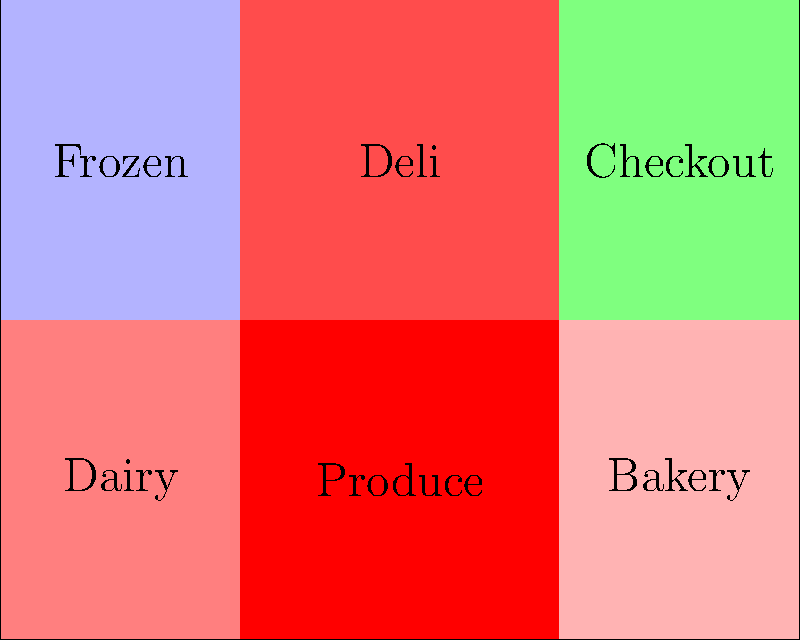Looking at the heat map of your store, which section seems to have the highest customer traffic, and what could you do to potentially increase sales in that area? To answer this question, let's analyze the heat map step-by-step:

1. The heat map uses colors to represent customer traffic, with red indicating high traffic and blue indicating low traffic.

2. Looking at the map, we can see that the Produce section is colored the darkest red, indicating it has the highest customer traffic.

3. The Deli section is the second most visited area, with a slightly lighter shade of red.

4. The Dairy and Bakery sections have moderate traffic, shown by lighter shades of red.

5. The Frozen section has the lowest traffic, indicated by the blue color.

6. The Checkout area is green, which likely represents a moderate but steady flow of customers.

To potentially increase sales in the high-traffic Produce section, you could:

1. Ensure ample stock of popular produce items to meet demand.
2. Place high-margin items or complementary products (like salad dressings or fruit dips) near popular produce.
3. Use attractive displays to showcase seasonal or specialty produce.
4. Offer samples of unique or new produce items to encourage purchases.
5. Place signs with recipe ideas using produce items to inspire additional purchases.

These strategies can help capitalize on the high foot traffic in the Produce section by encouraging customers to spend more time there and potentially increase their basket size.
Answer: Produce section; increase complementary product placement and sampling. 